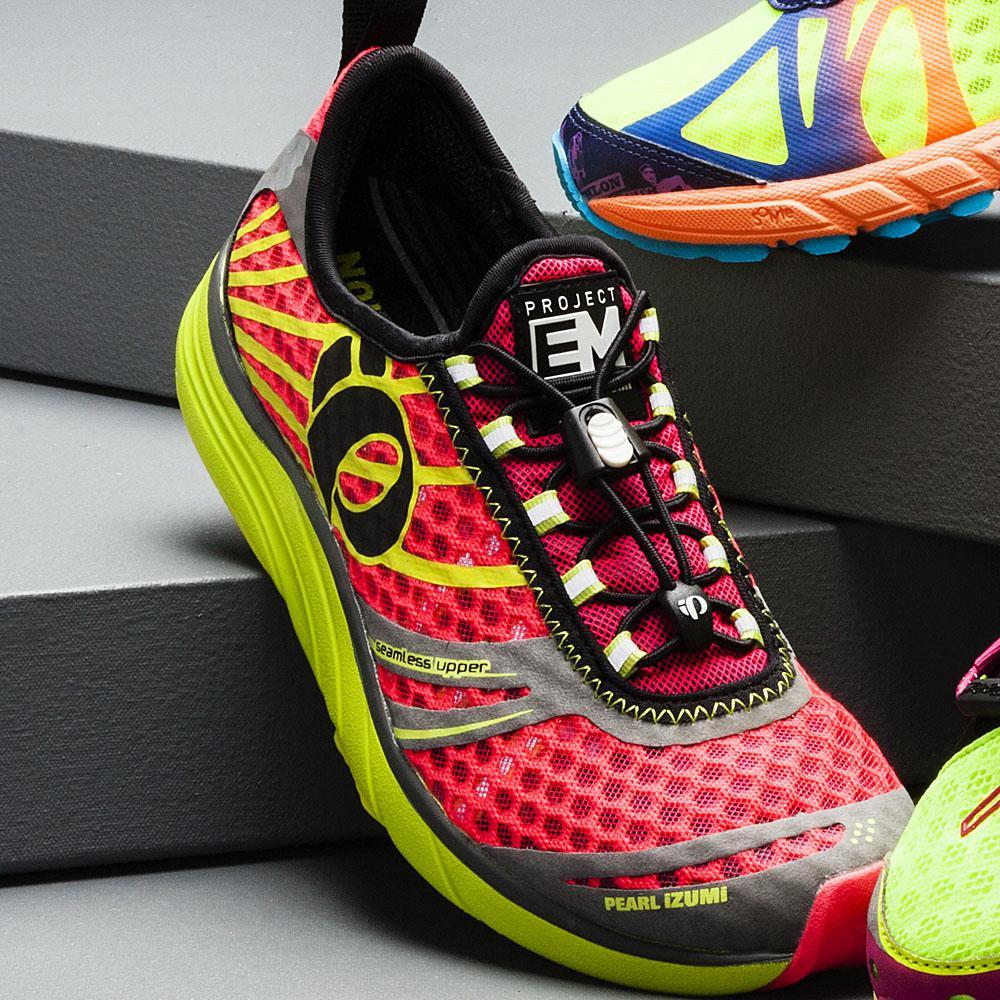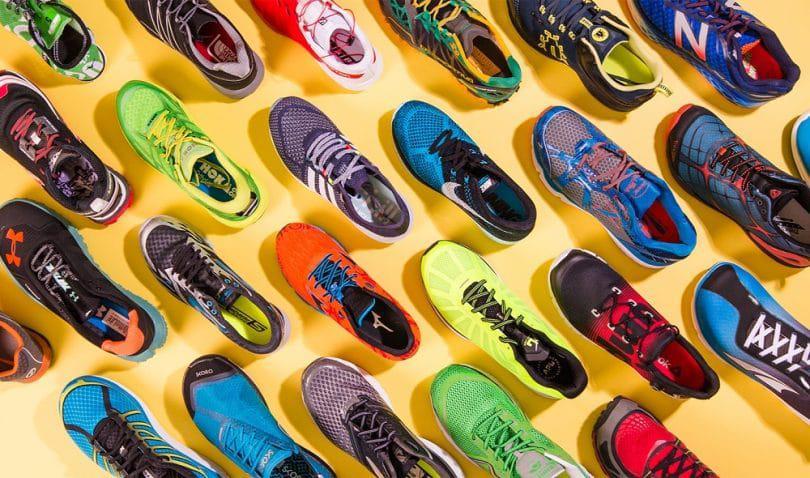The first image is the image on the left, the second image is the image on the right. Considering the images on both sides, is "No more than three sneakers are visible in the left image." valid? Answer yes or no. Yes. The first image is the image on the left, the second image is the image on the right. Considering the images on both sides, is "One of the images features no more than three shoes." valid? Answer yes or no. Yes. 